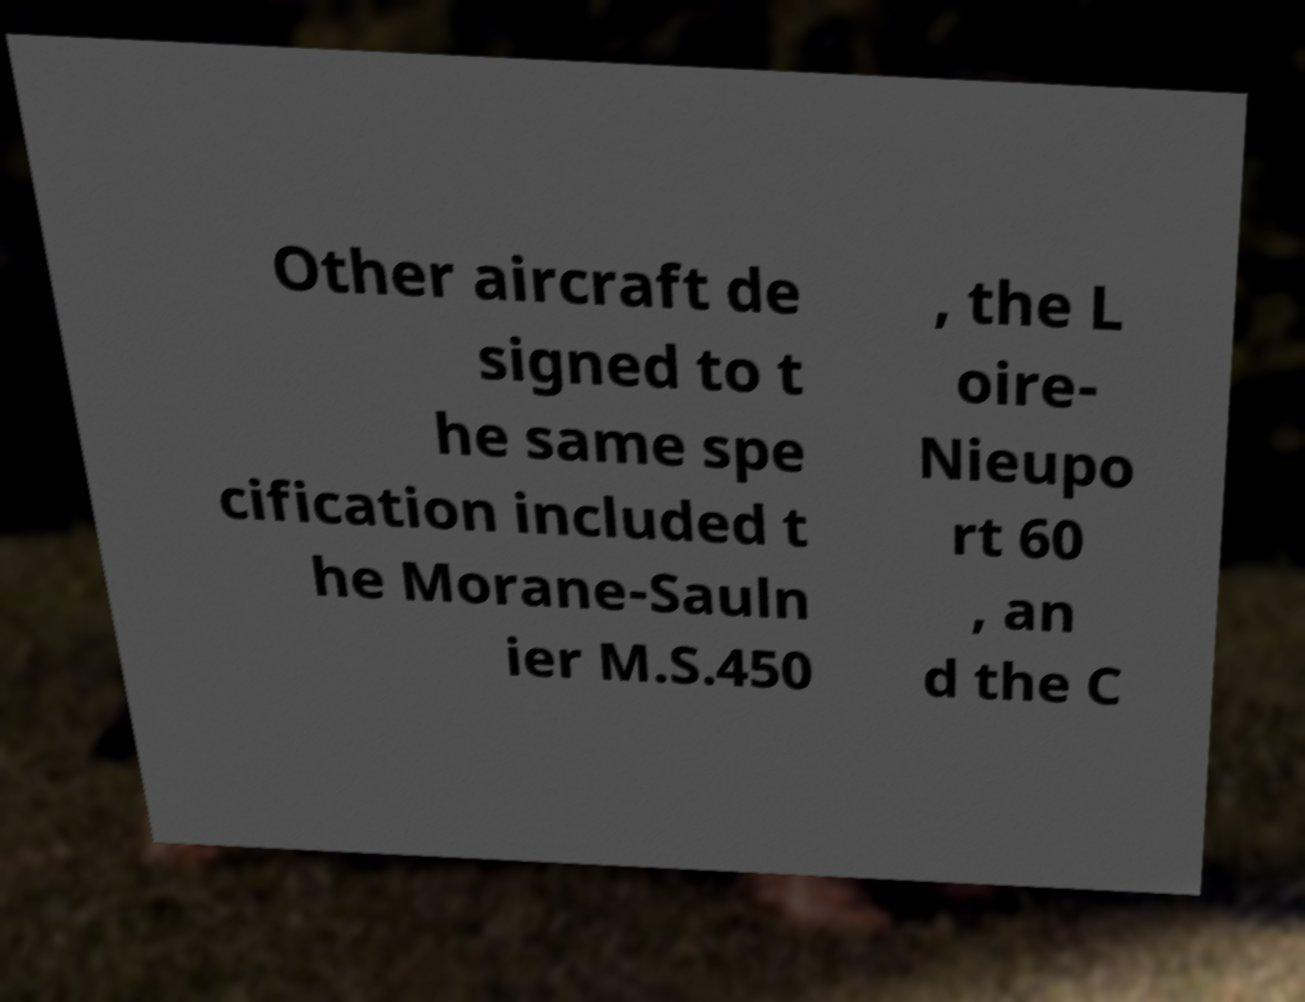For documentation purposes, I need the text within this image transcribed. Could you provide that? Other aircraft de signed to t he same spe cification included t he Morane-Sauln ier M.S.450 , the L oire- Nieupo rt 60 , an d the C 